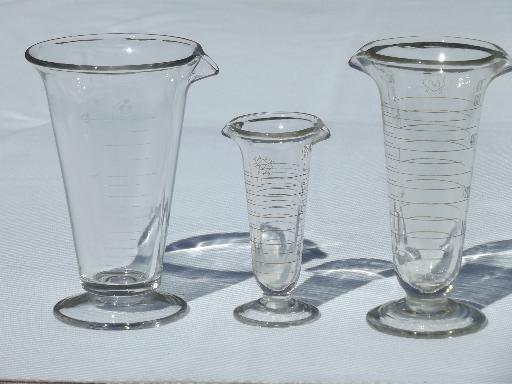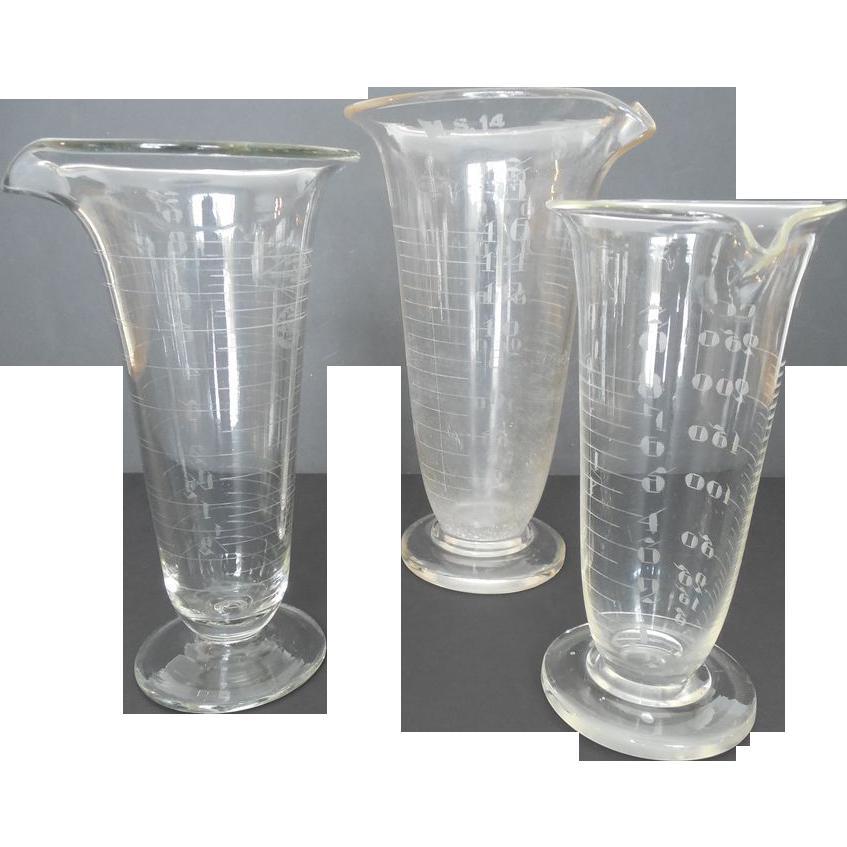The first image is the image on the left, the second image is the image on the right. Analyze the images presented: Is the assertion "The left and right image contains the same number of beakers." valid? Answer yes or no. Yes. The first image is the image on the left, the second image is the image on the right. For the images displayed, is the sentence "One image shows two footed beakers of the same height and one shorter footed beaker, all displayed upright." factually correct? Answer yes or no. Yes. 